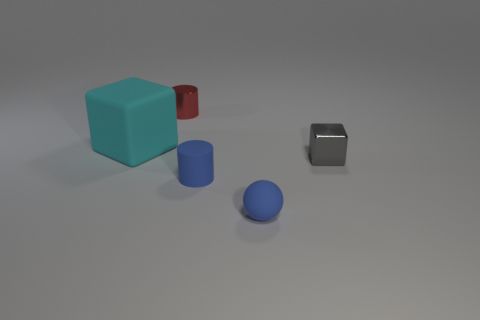There is a gray cube; is it the same size as the metallic thing behind the big rubber block?
Your answer should be very brief. Yes. What material is the tiny blue thing in front of the small blue thing behind the blue rubber sphere made of?
Offer a terse response. Rubber. Is the number of red shiny objects behind the shiny cylinder the same as the number of small green shiny things?
Your answer should be compact. Yes. There is a thing that is both behind the rubber cylinder and in front of the rubber cube; what size is it?
Your answer should be compact. Small. There is a rubber thing on the right side of the small cylinder in front of the tiny red cylinder; what color is it?
Your answer should be compact. Blue. How many blue things are big blocks or small spheres?
Give a very brief answer. 1. The small thing that is left of the gray cube and behind the blue cylinder is what color?
Offer a terse response. Red. How many small things are shiny blocks or yellow blocks?
Give a very brief answer. 1. There is another rubber thing that is the same shape as the red object; what is its size?
Make the answer very short. Small. What is the shape of the small red thing?
Your response must be concise. Cylinder. 